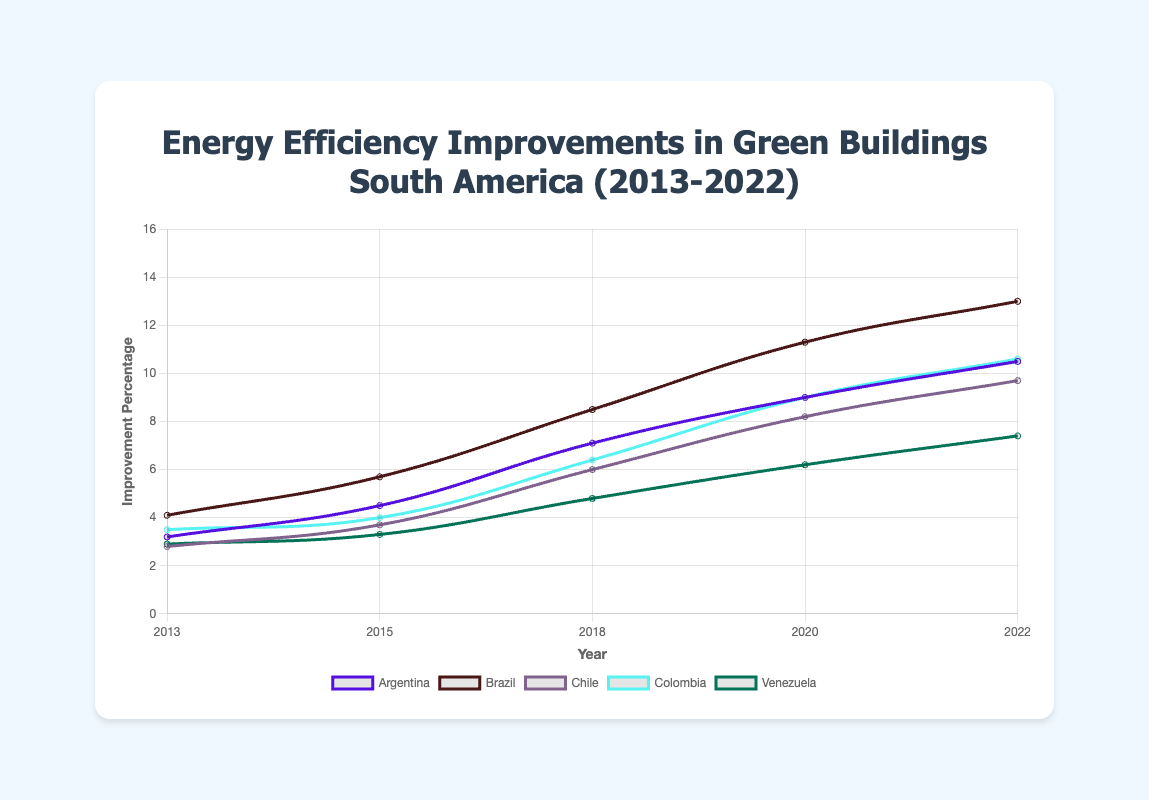What's the average energy efficiency improvement in 2022? To find the average, sum the improvement percentages of all countries in 2022 and divide by the number of countries: (10.5 + 13.0 + 9.7 + 10.6 + 7.4) / 5. The sum is 51.2, and the average is 51.2 / 5 = 10.24.
Answer: 10.24 Which country had the highest improvement percentage in 2020? Look at the line chart for the year 2020 and compare the values for each country: Argentina (9.0), Brazil (11.3), Chile (8.2), Colombia (9.0), Venezuela (6.2). The highest value is 11.3 for Brazil.
Answer: Brazil How did the improvement in Venezuela compare to Argentina over the decade? Compare the trend lines of Venezuela and Argentina from 2013 to 2022. Venezuela's improvement went from 2.9 to 7.4, while Argentina's went from 3.2 to 10.5. Both countries improved over time, but Argentina had a steeper increase and higher final value.
Answer: Argentina had a steeper increase and higher final value Which year showed the most significant improvement in energy efficiency for Brazil? Look at the improvement percentages for Brazil in each year: 2013 (4.1), 2015 (5.7), 2018 (8.5), 2020 (11.3), 2022 (13.0). Calculate the increase between consecutive years: 2013-2015: 1.6, 2015-2018: 2.8, 2018-2020: 2.8, 2020-2022: 1.7. The most significant improvement was from 2015 to 2018 and 2018 to 2020, both by 2.8.
Answer: 2015-2018 and 2018-2020 What's the difference in improvement percentage between Colombia and Chile in 2022? Find the improvement percentages for both countries in 2022: Colombia (10.6), Chile (9.7). Subtract Chile's value from Colombia's value: 10.6 - 9.7.
Answer: 0.9 Which country had the steadiest improvement trend over the decade? Compare the trend lines for all the countries. Brazil shows a steady and consistently upward trend from 4.1 to 13.0 over the decade.
Answer: Brazil In which year did Colombia’s improvement percentage match or exceed Argentina’s for the first time? Compare the values for Colombia and Argentina year by year: 2013: Colombia (3.5) and Argentina (3.2), 2015: Colombia (4.0) and Argentina (4.5), 2018: Colombia (6.4) and Argentina (7.1), 2020: Colombia (9.0) and Argentina (9.0), 2022: Colombia (10.6) and Argentina (10.5). In 2020, they matched at 9.0.
Answer: 2020 